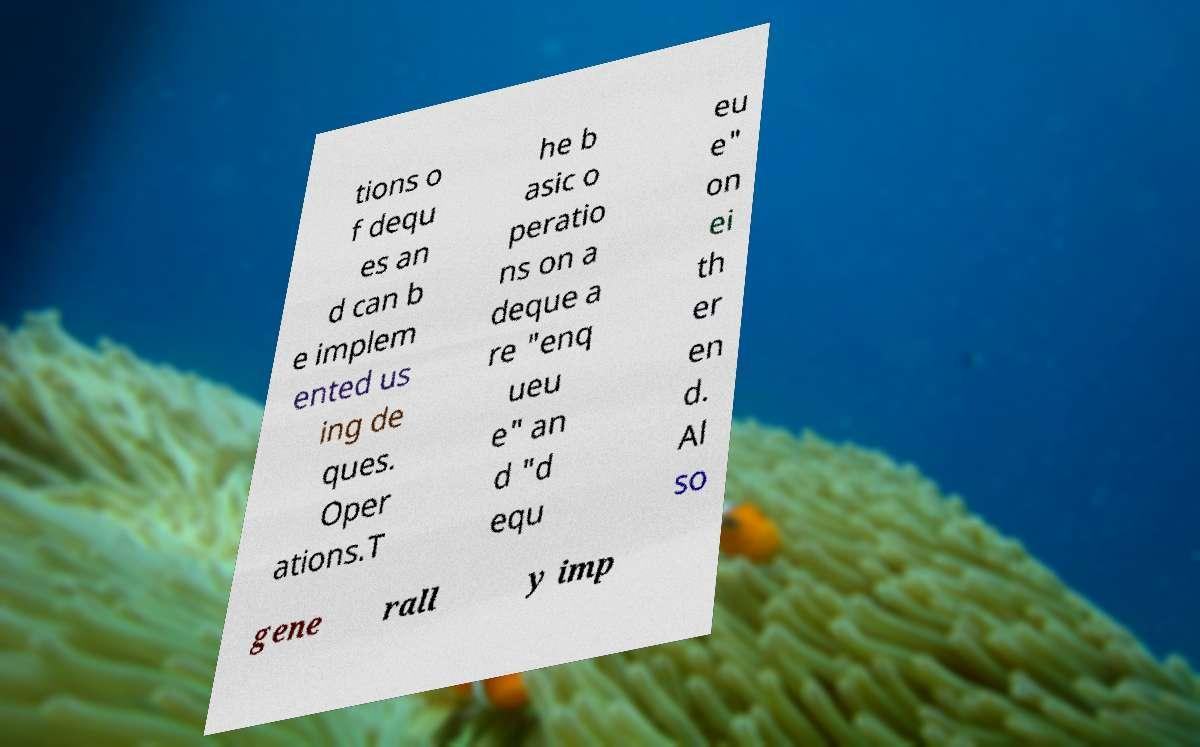For documentation purposes, I need the text within this image transcribed. Could you provide that? tions o f dequ es an d can b e implem ented us ing de ques. Oper ations.T he b asic o peratio ns on a deque a re "enq ueu e" an d "d equ eu e" on ei th er en d. Al so gene rall y imp 